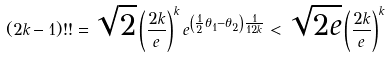Convert formula to latex. <formula><loc_0><loc_0><loc_500><loc_500>( 2 k - 1 ) ! ! = \sqrt { 2 } \left ( \frac { 2 k } { e } \right ) ^ { k } e ^ { \left ( \frac { 1 } { 2 } \theta _ { 1 } - \theta _ { 2 } \right ) \frac { 1 } { 1 2 k } } < \sqrt { 2 e } \left ( \frac { 2 k } { e } \right ) ^ { k }</formula> 